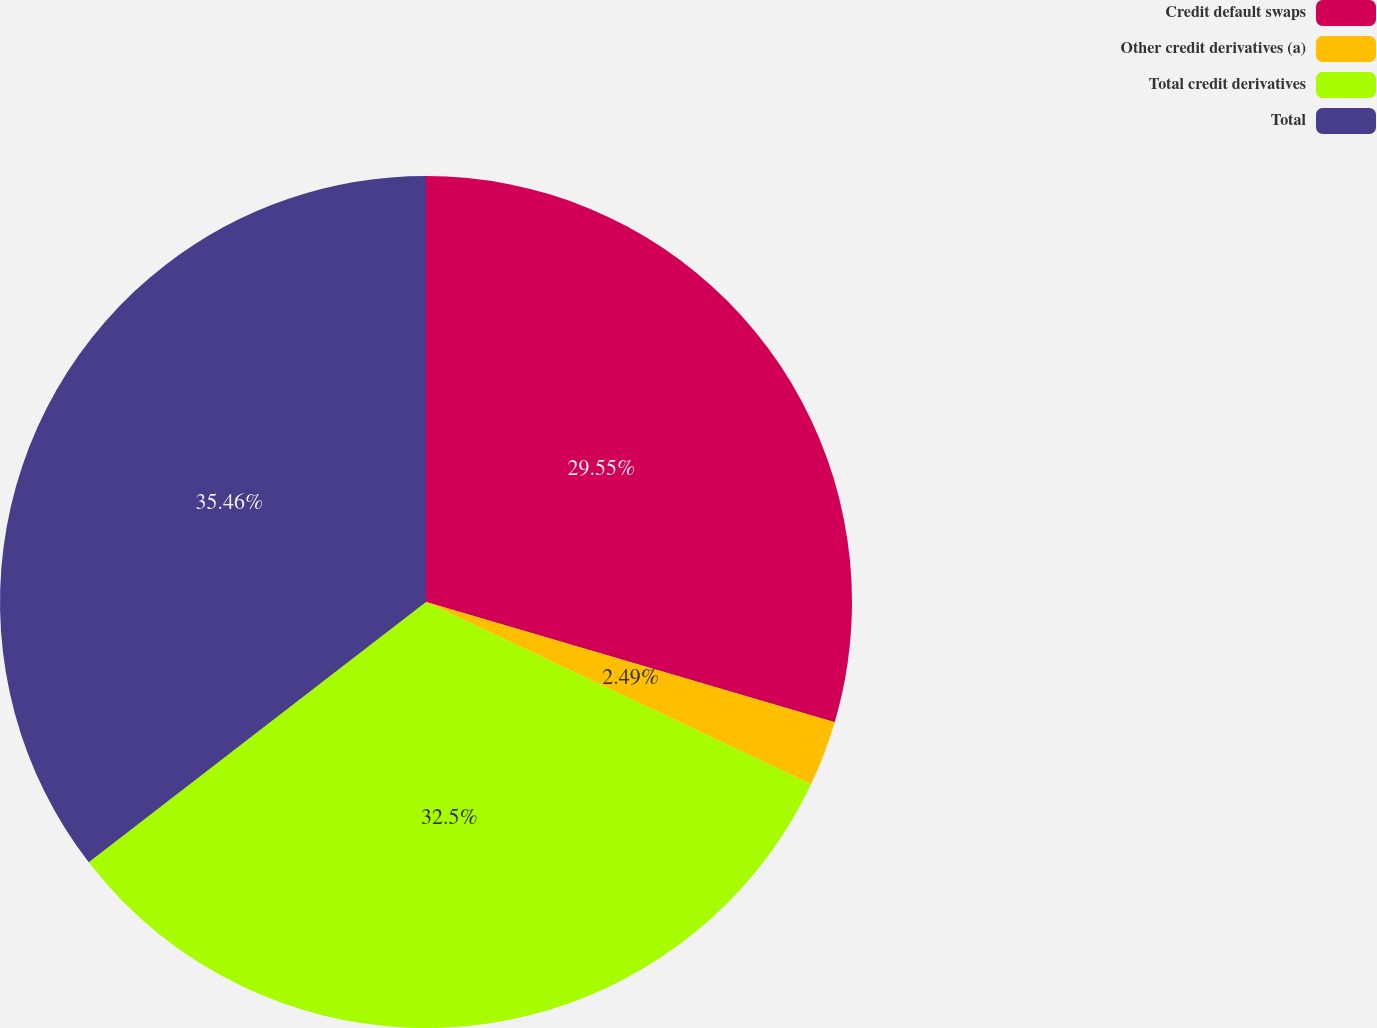<chart> <loc_0><loc_0><loc_500><loc_500><pie_chart><fcel>Credit default swaps<fcel>Other credit derivatives (a)<fcel>Total credit derivatives<fcel>Total<nl><fcel>29.55%<fcel>2.49%<fcel>32.5%<fcel>35.46%<nl></chart> 